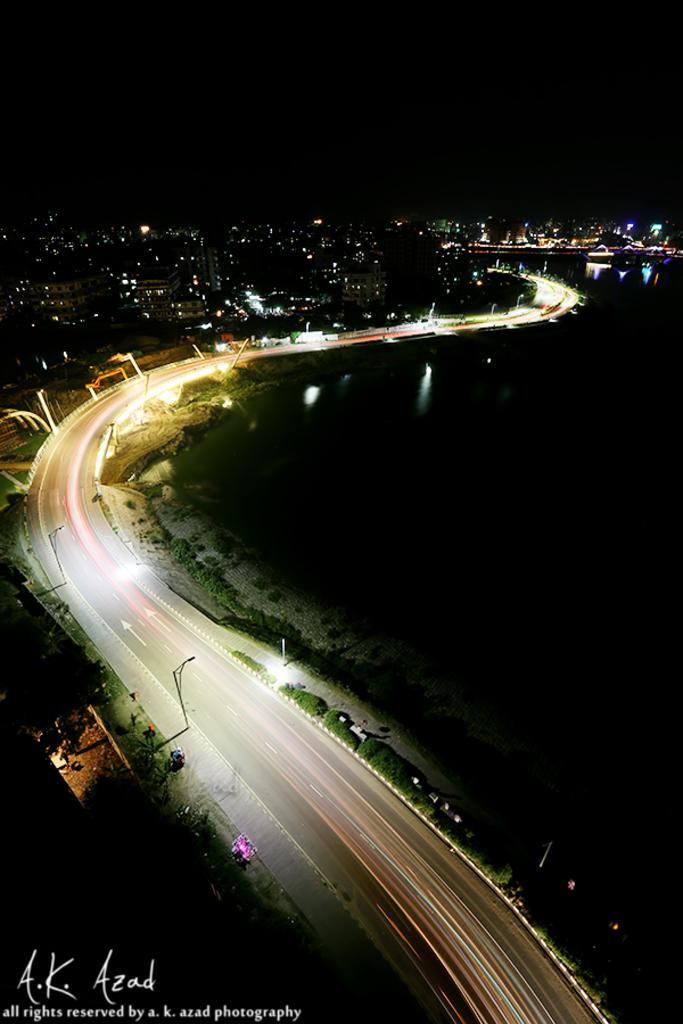Could you give a brief overview of what you see in this image? In this image we can see a road, poles, lights, trees, and buildings. There is a dark background. On the right side of the image we can see water. 